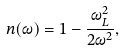<formula> <loc_0><loc_0><loc_500><loc_500>n ( \omega ) = 1 - \frac { \omega _ { L } ^ { 2 } } { 2 \omega ^ { 2 } } ,</formula> 